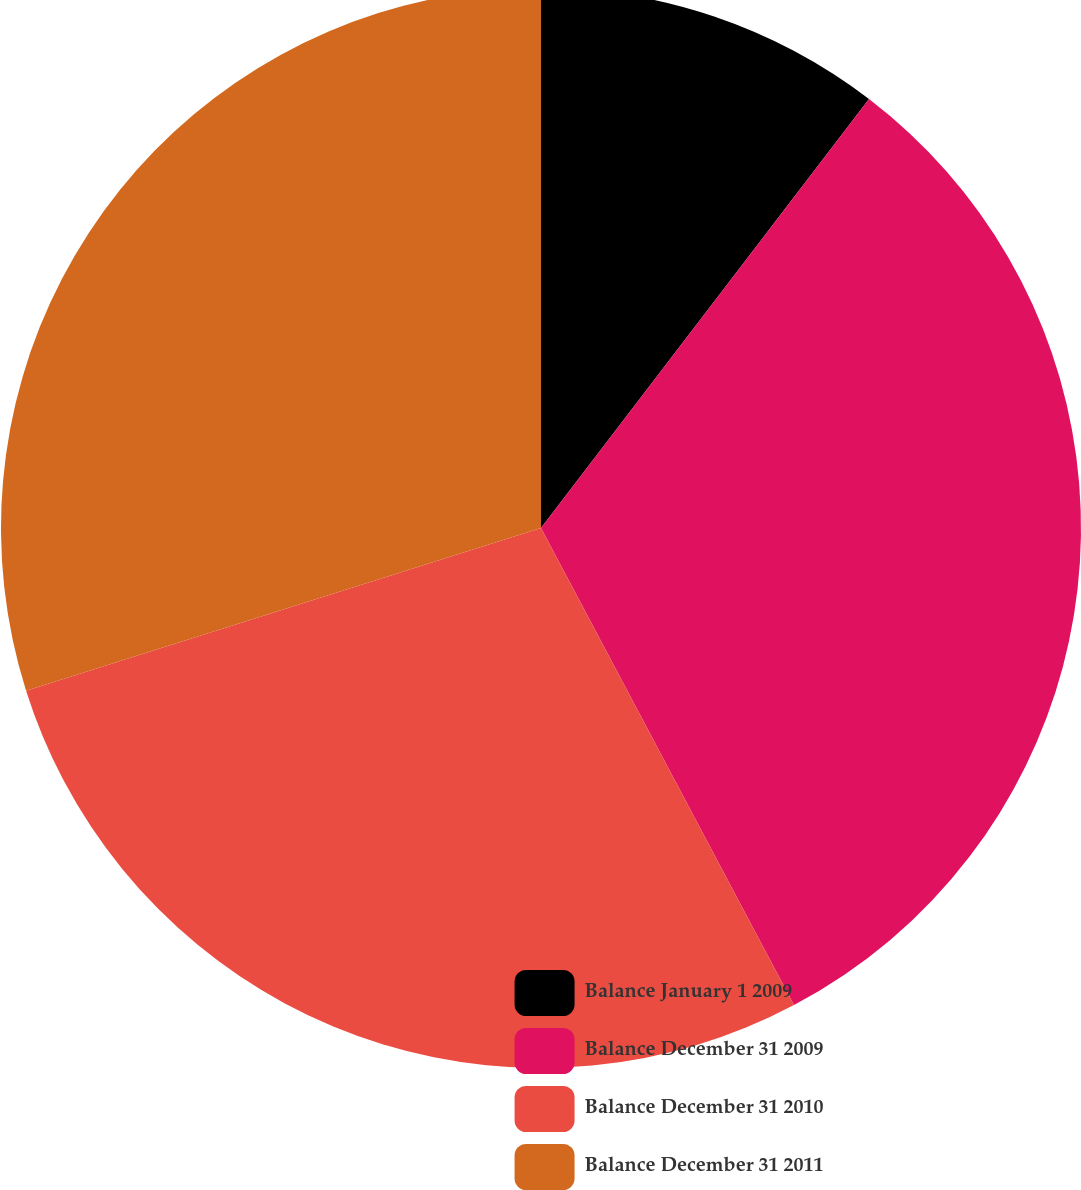Convert chart to OTSL. <chart><loc_0><loc_0><loc_500><loc_500><pie_chart><fcel>Balance January 1 2009<fcel>Balance December 31 2009<fcel>Balance December 31 2010<fcel>Balance December 31 2011<nl><fcel>10.39%<fcel>31.85%<fcel>27.89%<fcel>29.87%<nl></chart> 